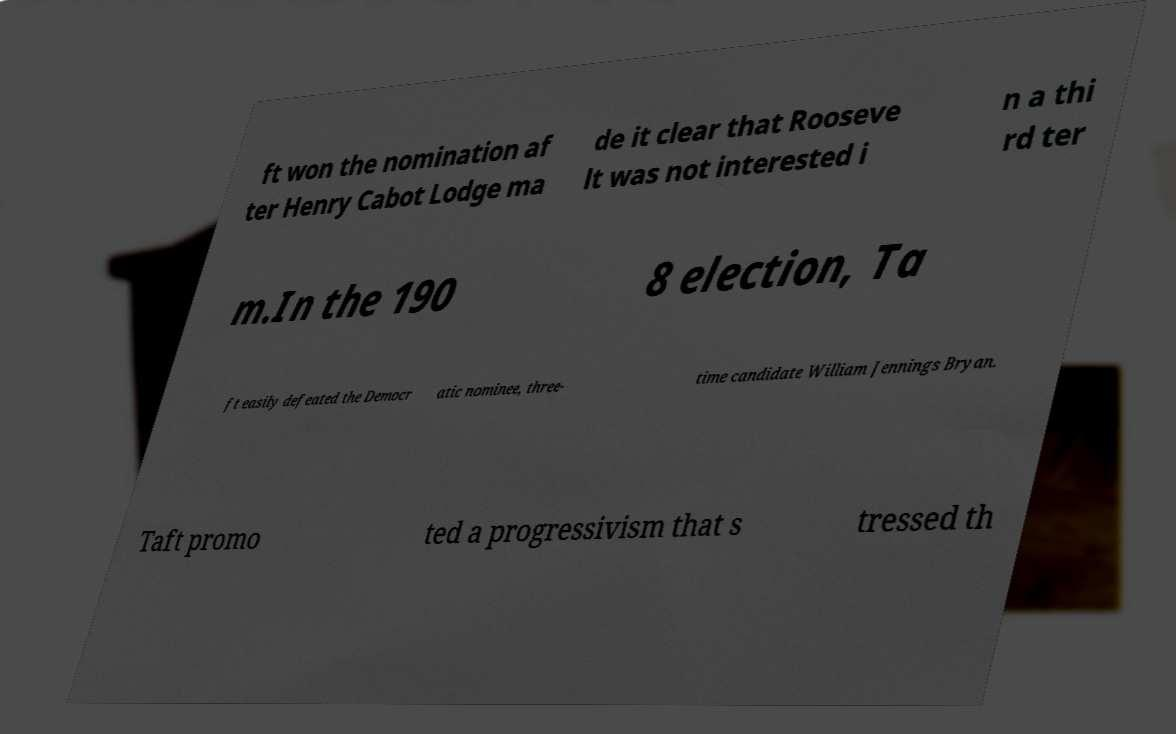Can you accurately transcribe the text from the provided image for me? ft won the nomination af ter Henry Cabot Lodge ma de it clear that Rooseve lt was not interested i n a thi rd ter m.In the 190 8 election, Ta ft easily defeated the Democr atic nominee, three- time candidate William Jennings Bryan. Taft promo ted a progressivism that s tressed th 